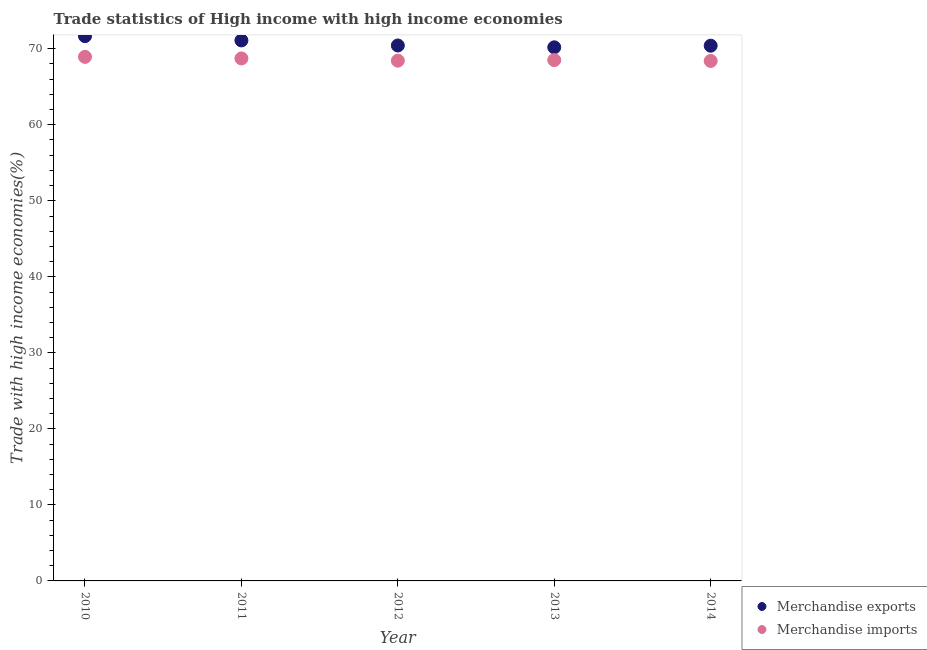What is the merchandise imports in 2014?
Give a very brief answer. 68.4. Across all years, what is the maximum merchandise exports?
Your response must be concise. 71.66. Across all years, what is the minimum merchandise exports?
Your response must be concise. 70.19. What is the total merchandise imports in the graph?
Your answer should be compact. 343.01. What is the difference between the merchandise imports in 2011 and that in 2012?
Give a very brief answer. 0.3. What is the difference between the merchandise imports in 2014 and the merchandise exports in 2012?
Offer a very short reply. -2.03. What is the average merchandise imports per year?
Ensure brevity in your answer.  68.6. In the year 2013, what is the difference between the merchandise imports and merchandise exports?
Offer a very short reply. -1.68. What is the ratio of the merchandise imports in 2013 to that in 2014?
Provide a short and direct response. 1. Is the merchandise imports in 2011 less than that in 2014?
Your response must be concise. No. Is the difference between the merchandise exports in 2010 and 2013 greater than the difference between the merchandise imports in 2010 and 2013?
Give a very brief answer. Yes. What is the difference between the highest and the second highest merchandise imports?
Ensure brevity in your answer.  0.21. What is the difference between the highest and the lowest merchandise imports?
Offer a terse response. 0.54. Is the sum of the merchandise exports in 2011 and 2013 greater than the maximum merchandise imports across all years?
Offer a terse response. Yes. How many years are there in the graph?
Your answer should be very brief. 5. Are the values on the major ticks of Y-axis written in scientific E-notation?
Your response must be concise. No. Does the graph contain any zero values?
Offer a very short reply. No. What is the title of the graph?
Provide a succinct answer. Trade statistics of High income with high income economies. What is the label or title of the X-axis?
Provide a succinct answer. Year. What is the label or title of the Y-axis?
Your answer should be very brief. Trade with high income economies(%). What is the Trade with high income economies(%) in Merchandise exports in 2010?
Your answer should be compact. 71.66. What is the Trade with high income economies(%) in Merchandise imports in 2010?
Make the answer very short. 68.94. What is the Trade with high income economies(%) in Merchandise exports in 2011?
Your answer should be very brief. 71.1. What is the Trade with high income economies(%) in Merchandise imports in 2011?
Your response must be concise. 68.73. What is the Trade with high income economies(%) of Merchandise exports in 2012?
Make the answer very short. 70.43. What is the Trade with high income economies(%) of Merchandise imports in 2012?
Keep it short and to the point. 68.43. What is the Trade with high income economies(%) of Merchandise exports in 2013?
Offer a very short reply. 70.19. What is the Trade with high income economies(%) of Merchandise imports in 2013?
Your response must be concise. 68.51. What is the Trade with high income economies(%) of Merchandise exports in 2014?
Keep it short and to the point. 70.4. What is the Trade with high income economies(%) of Merchandise imports in 2014?
Ensure brevity in your answer.  68.4. Across all years, what is the maximum Trade with high income economies(%) of Merchandise exports?
Make the answer very short. 71.66. Across all years, what is the maximum Trade with high income economies(%) of Merchandise imports?
Your answer should be compact. 68.94. Across all years, what is the minimum Trade with high income economies(%) of Merchandise exports?
Your answer should be compact. 70.19. Across all years, what is the minimum Trade with high income economies(%) in Merchandise imports?
Provide a succinct answer. 68.4. What is the total Trade with high income economies(%) of Merchandise exports in the graph?
Provide a succinct answer. 353.78. What is the total Trade with high income economies(%) of Merchandise imports in the graph?
Your response must be concise. 343.01. What is the difference between the Trade with high income economies(%) in Merchandise exports in 2010 and that in 2011?
Your answer should be compact. 0.57. What is the difference between the Trade with high income economies(%) in Merchandise imports in 2010 and that in 2011?
Make the answer very short. 0.21. What is the difference between the Trade with high income economies(%) in Merchandise exports in 2010 and that in 2012?
Ensure brevity in your answer.  1.23. What is the difference between the Trade with high income economies(%) of Merchandise imports in 2010 and that in 2012?
Your response must be concise. 0.5. What is the difference between the Trade with high income economies(%) of Merchandise exports in 2010 and that in 2013?
Ensure brevity in your answer.  1.47. What is the difference between the Trade with high income economies(%) in Merchandise imports in 2010 and that in 2013?
Your response must be concise. 0.42. What is the difference between the Trade with high income economies(%) in Merchandise exports in 2010 and that in 2014?
Keep it short and to the point. 1.26. What is the difference between the Trade with high income economies(%) of Merchandise imports in 2010 and that in 2014?
Your answer should be compact. 0.54. What is the difference between the Trade with high income economies(%) in Merchandise exports in 2011 and that in 2012?
Offer a terse response. 0.67. What is the difference between the Trade with high income economies(%) of Merchandise imports in 2011 and that in 2012?
Provide a short and direct response. 0.3. What is the difference between the Trade with high income economies(%) in Merchandise exports in 2011 and that in 2013?
Provide a short and direct response. 0.91. What is the difference between the Trade with high income economies(%) of Merchandise imports in 2011 and that in 2013?
Your answer should be compact. 0.22. What is the difference between the Trade with high income economies(%) in Merchandise exports in 2011 and that in 2014?
Keep it short and to the point. 0.69. What is the difference between the Trade with high income economies(%) in Merchandise imports in 2011 and that in 2014?
Provide a short and direct response. 0.33. What is the difference between the Trade with high income economies(%) in Merchandise exports in 2012 and that in 2013?
Give a very brief answer. 0.24. What is the difference between the Trade with high income economies(%) of Merchandise imports in 2012 and that in 2013?
Your answer should be very brief. -0.08. What is the difference between the Trade with high income economies(%) of Merchandise exports in 2012 and that in 2014?
Your answer should be very brief. 0.03. What is the difference between the Trade with high income economies(%) in Merchandise imports in 2012 and that in 2014?
Your response must be concise. 0.04. What is the difference between the Trade with high income economies(%) of Merchandise exports in 2013 and that in 2014?
Ensure brevity in your answer.  -0.21. What is the difference between the Trade with high income economies(%) of Merchandise imports in 2013 and that in 2014?
Ensure brevity in your answer.  0.11. What is the difference between the Trade with high income economies(%) in Merchandise exports in 2010 and the Trade with high income economies(%) in Merchandise imports in 2011?
Make the answer very short. 2.93. What is the difference between the Trade with high income economies(%) in Merchandise exports in 2010 and the Trade with high income economies(%) in Merchandise imports in 2012?
Keep it short and to the point. 3.23. What is the difference between the Trade with high income economies(%) of Merchandise exports in 2010 and the Trade with high income economies(%) of Merchandise imports in 2013?
Make the answer very short. 3.15. What is the difference between the Trade with high income economies(%) of Merchandise exports in 2010 and the Trade with high income economies(%) of Merchandise imports in 2014?
Offer a terse response. 3.27. What is the difference between the Trade with high income economies(%) in Merchandise exports in 2011 and the Trade with high income economies(%) in Merchandise imports in 2012?
Provide a short and direct response. 2.66. What is the difference between the Trade with high income economies(%) in Merchandise exports in 2011 and the Trade with high income economies(%) in Merchandise imports in 2013?
Provide a succinct answer. 2.59. What is the difference between the Trade with high income economies(%) in Merchandise exports in 2011 and the Trade with high income economies(%) in Merchandise imports in 2014?
Keep it short and to the point. 2.7. What is the difference between the Trade with high income economies(%) of Merchandise exports in 2012 and the Trade with high income economies(%) of Merchandise imports in 2013?
Keep it short and to the point. 1.92. What is the difference between the Trade with high income economies(%) in Merchandise exports in 2012 and the Trade with high income economies(%) in Merchandise imports in 2014?
Provide a succinct answer. 2.03. What is the difference between the Trade with high income economies(%) in Merchandise exports in 2013 and the Trade with high income economies(%) in Merchandise imports in 2014?
Your response must be concise. 1.79. What is the average Trade with high income economies(%) in Merchandise exports per year?
Give a very brief answer. 70.76. What is the average Trade with high income economies(%) of Merchandise imports per year?
Ensure brevity in your answer.  68.6. In the year 2010, what is the difference between the Trade with high income economies(%) in Merchandise exports and Trade with high income economies(%) in Merchandise imports?
Ensure brevity in your answer.  2.73. In the year 2011, what is the difference between the Trade with high income economies(%) of Merchandise exports and Trade with high income economies(%) of Merchandise imports?
Your answer should be very brief. 2.37. In the year 2012, what is the difference between the Trade with high income economies(%) of Merchandise exports and Trade with high income economies(%) of Merchandise imports?
Your answer should be compact. 2. In the year 2013, what is the difference between the Trade with high income economies(%) of Merchandise exports and Trade with high income economies(%) of Merchandise imports?
Your answer should be very brief. 1.68. In the year 2014, what is the difference between the Trade with high income economies(%) in Merchandise exports and Trade with high income economies(%) in Merchandise imports?
Ensure brevity in your answer.  2.01. What is the ratio of the Trade with high income economies(%) in Merchandise exports in 2010 to that in 2012?
Ensure brevity in your answer.  1.02. What is the ratio of the Trade with high income economies(%) of Merchandise imports in 2010 to that in 2012?
Provide a succinct answer. 1.01. What is the ratio of the Trade with high income economies(%) in Merchandise exports in 2010 to that in 2013?
Your answer should be compact. 1.02. What is the ratio of the Trade with high income economies(%) of Merchandise imports in 2010 to that in 2013?
Ensure brevity in your answer.  1.01. What is the ratio of the Trade with high income economies(%) of Merchandise exports in 2010 to that in 2014?
Provide a succinct answer. 1.02. What is the ratio of the Trade with high income economies(%) of Merchandise imports in 2010 to that in 2014?
Your answer should be very brief. 1.01. What is the ratio of the Trade with high income economies(%) in Merchandise exports in 2011 to that in 2012?
Offer a very short reply. 1.01. What is the ratio of the Trade with high income economies(%) in Merchandise exports in 2011 to that in 2013?
Ensure brevity in your answer.  1.01. What is the ratio of the Trade with high income economies(%) of Merchandise imports in 2011 to that in 2013?
Offer a terse response. 1. What is the ratio of the Trade with high income economies(%) in Merchandise exports in 2011 to that in 2014?
Make the answer very short. 1.01. What is the ratio of the Trade with high income economies(%) in Merchandise imports in 2011 to that in 2014?
Keep it short and to the point. 1. What is the ratio of the Trade with high income economies(%) in Merchandise exports in 2012 to that in 2014?
Make the answer very short. 1. What is the ratio of the Trade with high income economies(%) in Merchandise imports in 2012 to that in 2014?
Give a very brief answer. 1. What is the ratio of the Trade with high income economies(%) of Merchandise exports in 2013 to that in 2014?
Provide a succinct answer. 1. What is the difference between the highest and the second highest Trade with high income economies(%) in Merchandise exports?
Give a very brief answer. 0.57. What is the difference between the highest and the second highest Trade with high income economies(%) of Merchandise imports?
Your answer should be compact. 0.21. What is the difference between the highest and the lowest Trade with high income economies(%) in Merchandise exports?
Ensure brevity in your answer.  1.47. What is the difference between the highest and the lowest Trade with high income economies(%) of Merchandise imports?
Your response must be concise. 0.54. 